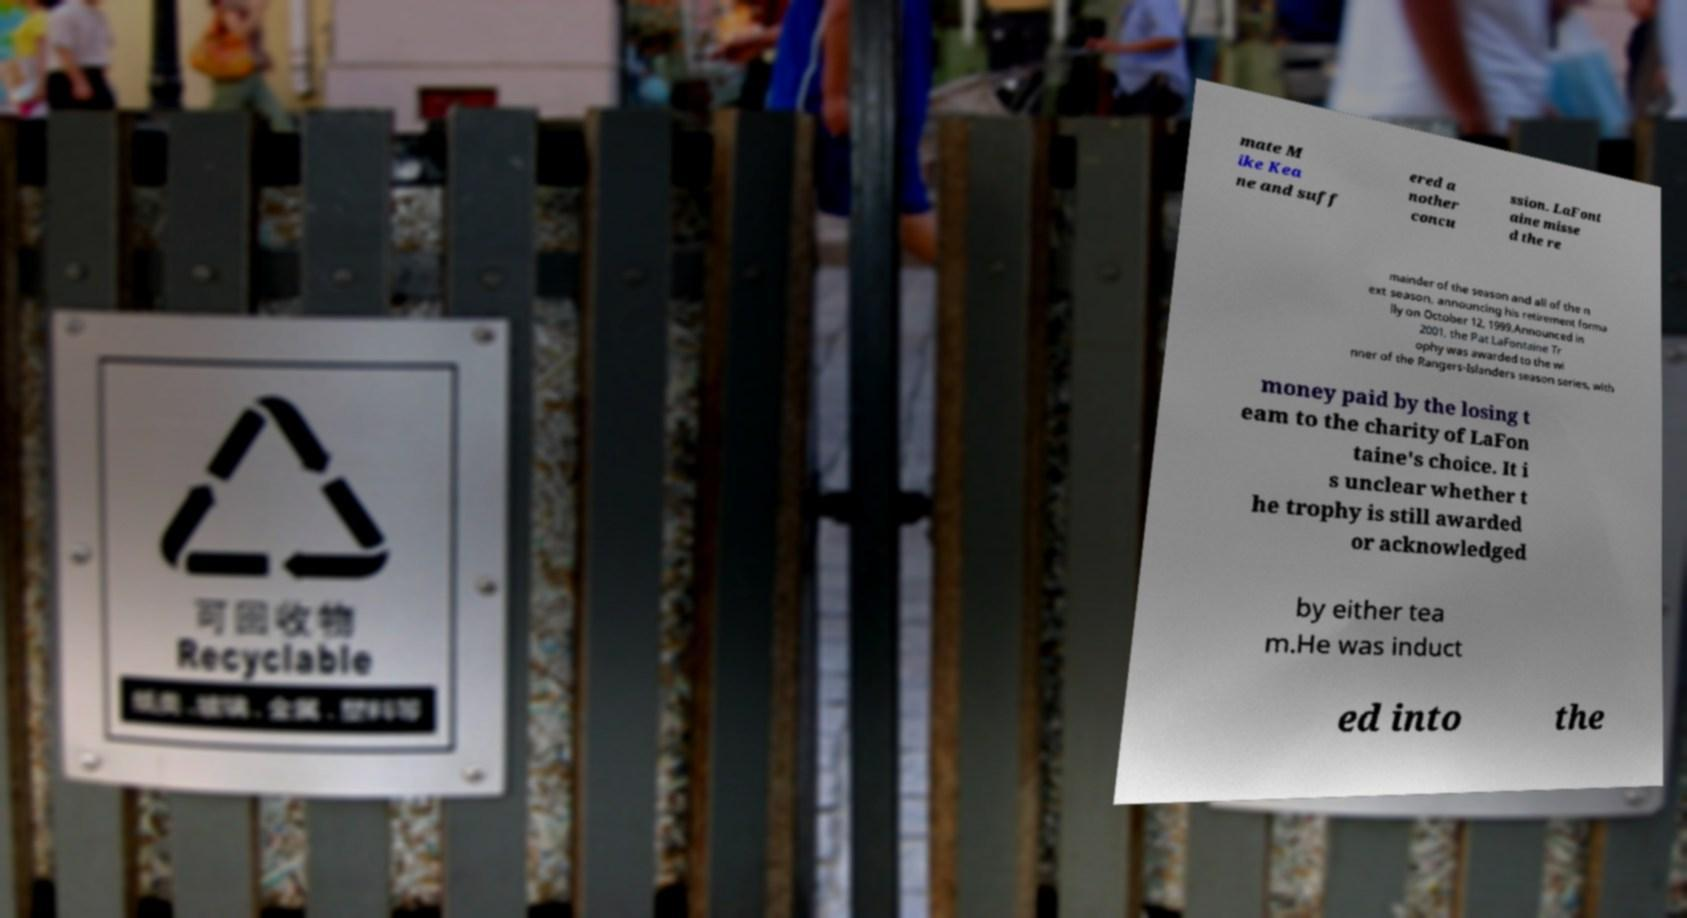Please read and relay the text visible in this image. What does it say? mate M ike Kea ne and suff ered a nother concu ssion. LaFont aine misse d the re mainder of the season and all of the n ext season, announcing his retirement forma lly on October 12, 1999.Announced in 2001, the Pat LaFontaine Tr ophy was awarded to the wi nner of the Rangers-Islanders season series, with money paid by the losing t eam to the charity of LaFon taine's choice. It i s unclear whether t he trophy is still awarded or acknowledged by either tea m.He was induct ed into the 